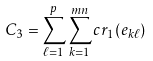Convert formula to latex. <formula><loc_0><loc_0><loc_500><loc_500>C _ { 3 } = \sum _ { \ell = 1 } ^ { p } \sum _ { k = 1 } ^ { m n } c r _ { 1 } ( e _ { k \ell } )</formula> 